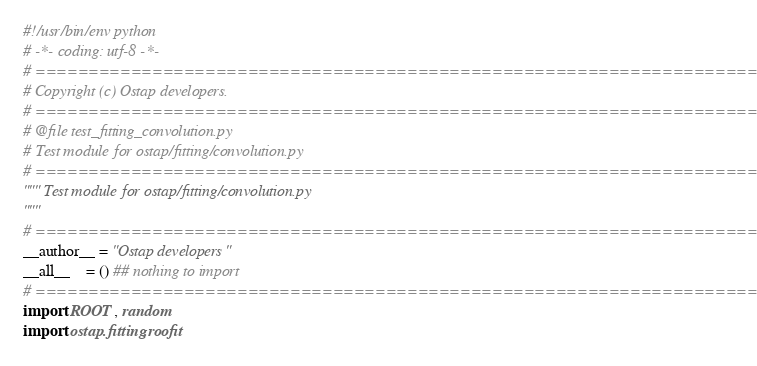<code> <loc_0><loc_0><loc_500><loc_500><_Python_>#!/usr/bin/env python
# -*- coding: utf-8 -*-
# =============================================================================
# Copyright (c) Ostap developers.
# ============================================================================= 
# @file test_fitting_convolution.py
# Test module for ostap/fitting/convolution.py
# ============================================================================= 
""" Test module for ostap/fitting/convolution.py
"""
# ============================================================================= 
__author__ = "Ostap developers"
__all__    = () ## nothing to import
# ============================================================================= 
import ROOT, random
import ostap.fitting.roofit </code> 